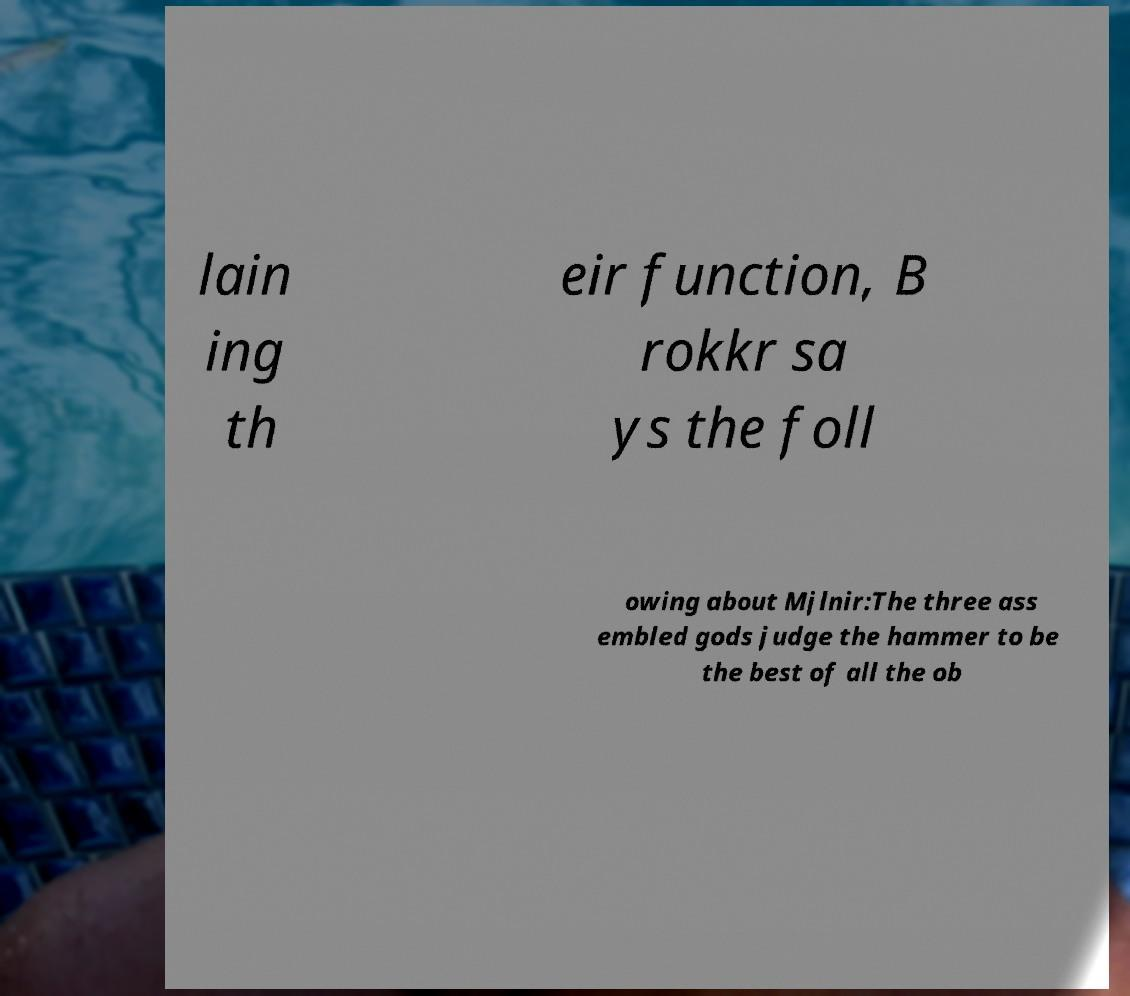Could you extract and type out the text from this image? lain ing th eir function, B rokkr sa ys the foll owing about Mjlnir:The three ass embled gods judge the hammer to be the best of all the ob 